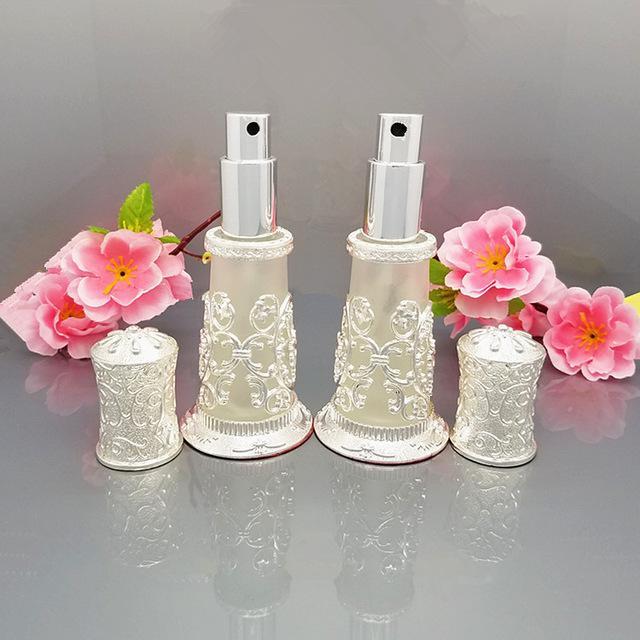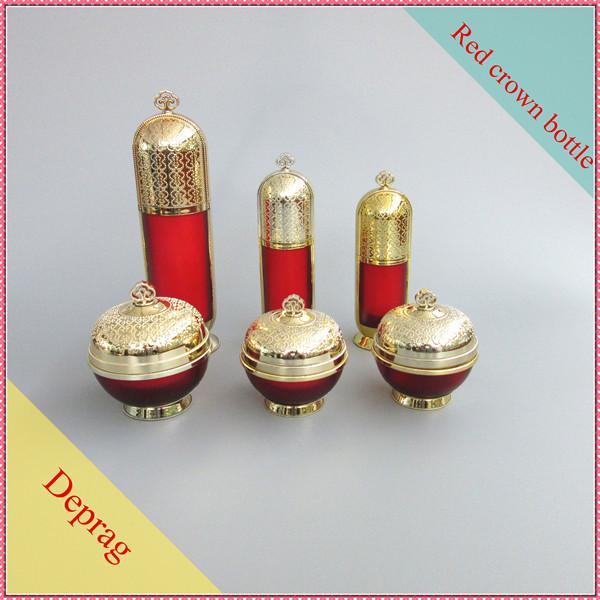The first image is the image on the left, the second image is the image on the right. Examine the images to the left and right. Is the description "There are two containers in one of the images." accurate? Answer yes or no. Yes. 